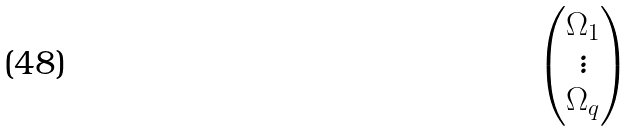<formula> <loc_0><loc_0><loc_500><loc_500>\begin{pmatrix} \Omega _ { 1 } \\ \vdots \\ \Omega _ { q } \end{pmatrix}</formula> 